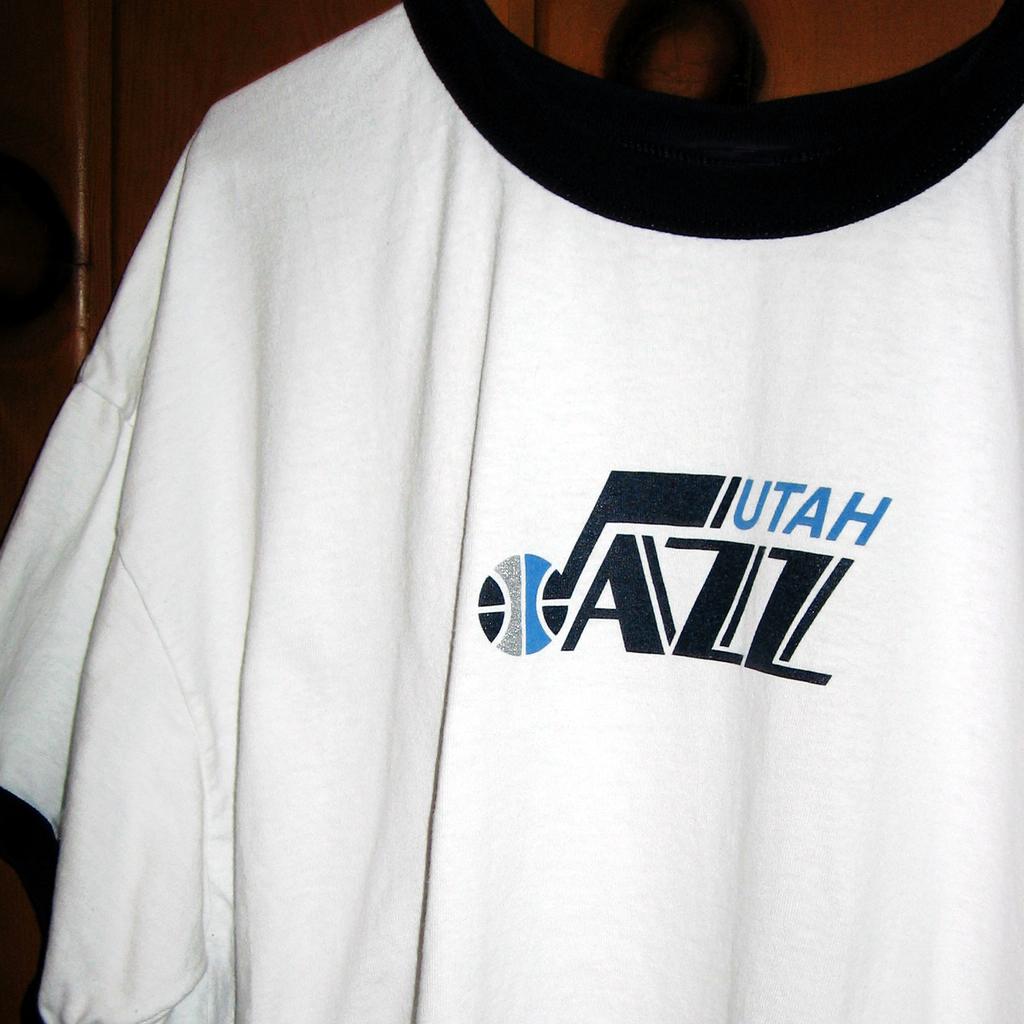Whats the name of the team written on the jersey?
Offer a very short reply. Utah jazz. 